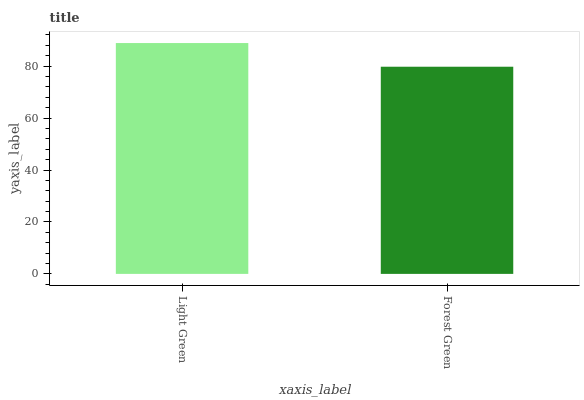Is Forest Green the minimum?
Answer yes or no. Yes. Is Light Green the maximum?
Answer yes or no. Yes. Is Forest Green the maximum?
Answer yes or no. No. Is Light Green greater than Forest Green?
Answer yes or no. Yes. Is Forest Green less than Light Green?
Answer yes or no. Yes. Is Forest Green greater than Light Green?
Answer yes or no. No. Is Light Green less than Forest Green?
Answer yes or no. No. Is Light Green the high median?
Answer yes or no. Yes. Is Forest Green the low median?
Answer yes or no. Yes. Is Forest Green the high median?
Answer yes or no. No. Is Light Green the low median?
Answer yes or no. No. 